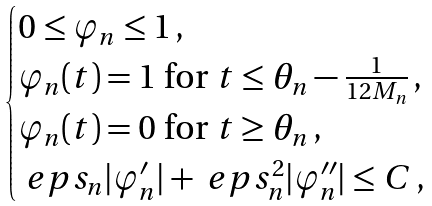<formula> <loc_0><loc_0><loc_500><loc_500>\begin{cases} 0 \leq \varphi _ { n } \leq 1 \, , \\ \varphi _ { n } ( t ) = 1 \text { for } t \leq \theta _ { n } - \frac { 1 } { 1 2 M _ { n } } \, , \\ \varphi _ { n } ( t ) = 0 \text { for } t \geq \theta _ { n } \, , \\ \ e p s _ { n } | \varphi _ { n } ^ { \prime } | + \ e p s _ { n } ^ { 2 } | \varphi _ { n } ^ { \prime \prime } | \leq C \, , \end{cases}</formula> 